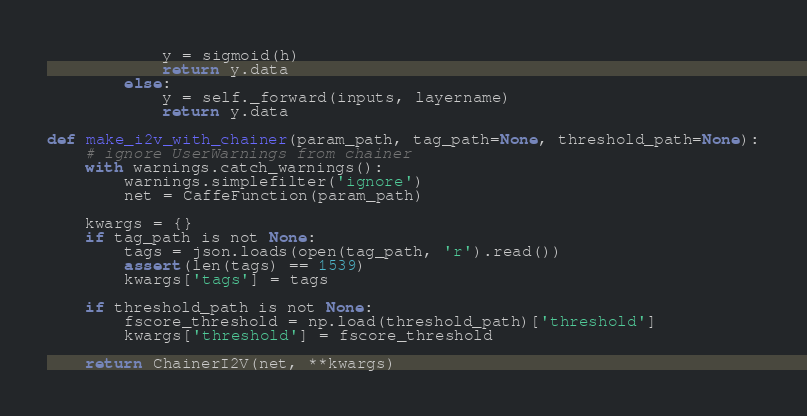<code> <loc_0><loc_0><loc_500><loc_500><_Python_>            y = sigmoid(h)
            return y.data
        else:
            y = self._forward(inputs, layername)
            return y.data

def make_i2v_with_chainer(param_path, tag_path=None, threshold_path=None):
    # ignore UserWarnings from chainer
    with warnings.catch_warnings():
        warnings.simplefilter('ignore')
        net = CaffeFunction(param_path)

    kwargs = {}
    if tag_path is not None:
        tags = json.loads(open(tag_path, 'r').read())
        assert(len(tags) == 1539)
        kwargs['tags'] = tags

    if threshold_path is not None:
        fscore_threshold = np.load(threshold_path)['threshold']
        kwargs['threshold'] = fscore_threshold

    return ChainerI2V(net, **kwargs)
</code> 